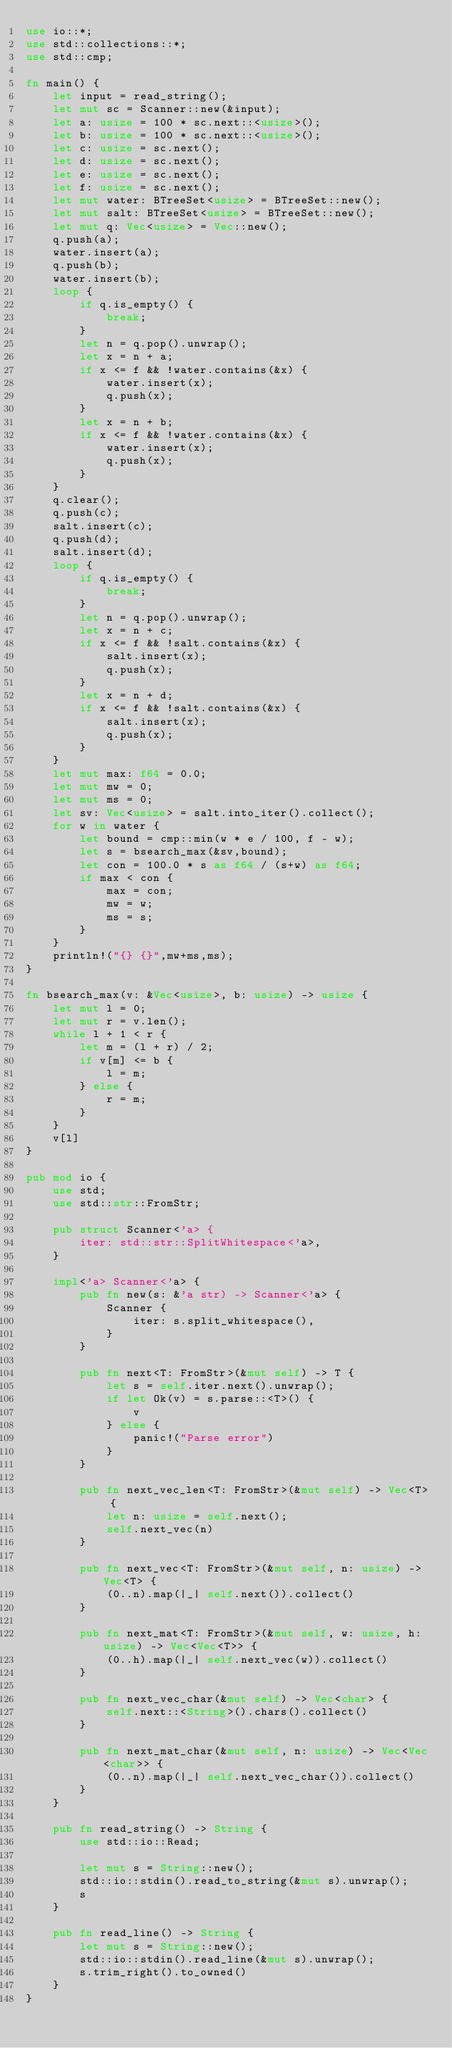<code> <loc_0><loc_0><loc_500><loc_500><_Rust_>use io::*;
use std::collections::*;
use std::cmp;

fn main() {
    let input = read_string();
    let mut sc = Scanner::new(&input);
    let a: usize = 100 * sc.next::<usize>();
    let b: usize = 100 * sc.next::<usize>();
    let c: usize = sc.next();
    let d: usize = sc.next();
    let e: usize = sc.next();
    let f: usize = sc.next();
    let mut water: BTreeSet<usize> = BTreeSet::new();
    let mut salt: BTreeSet<usize> = BTreeSet::new();
    let mut q: Vec<usize> = Vec::new();
    q.push(a);
    water.insert(a);
    q.push(b);
    water.insert(b);
    loop {
        if q.is_empty() {
            break;
        }
        let n = q.pop().unwrap();
        let x = n + a;
        if x <= f && !water.contains(&x) {
            water.insert(x);
            q.push(x);
        }
        let x = n + b;
        if x <= f && !water.contains(&x) {
            water.insert(x);
            q.push(x);
        }
    }
    q.clear();
    q.push(c);
    salt.insert(c);
    q.push(d);
    salt.insert(d);
    loop {
        if q.is_empty() {
            break;
        }
        let n = q.pop().unwrap();
        let x = n + c;
        if x <= f && !salt.contains(&x) {
            salt.insert(x);
            q.push(x);
        }
        let x = n + d;
        if x <= f && !salt.contains(&x) {
            salt.insert(x);
            q.push(x);
        }
    }
    let mut max: f64 = 0.0;
    let mut mw = 0;
    let mut ms = 0;
    let sv: Vec<usize> = salt.into_iter().collect();
    for w in water {
        let bound = cmp::min(w * e / 100, f - w);
        let s = bsearch_max(&sv,bound);
        let con = 100.0 * s as f64 / (s+w) as f64;
        if max < con {
            max = con;
            mw = w;
            ms = s;
        }
    }
    println!("{} {}",mw+ms,ms);
}

fn bsearch_max(v: &Vec<usize>, b: usize) -> usize {
    let mut l = 0;
    let mut r = v.len();
    while l + 1 < r {
        let m = (l + r) / 2;
        if v[m] <= b {
            l = m;
        } else {
            r = m;
        }
    }
    v[l]
}

pub mod io {
    use std;
    use std::str::FromStr;

    pub struct Scanner<'a> {
        iter: std::str::SplitWhitespace<'a>,
    }

    impl<'a> Scanner<'a> {
        pub fn new(s: &'a str) -> Scanner<'a> {
            Scanner {
                iter: s.split_whitespace(),
            }
        }

        pub fn next<T: FromStr>(&mut self) -> T {
            let s = self.iter.next().unwrap();
            if let Ok(v) = s.parse::<T>() {
                v
            } else {
                panic!("Parse error")
            }
        }

        pub fn next_vec_len<T: FromStr>(&mut self) -> Vec<T> {
            let n: usize = self.next();
            self.next_vec(n)
        }

        pub fn next_vec<T: FromStr>(&mut self, n: usize) -> Vec<T> {
            (0..n).map(|_| self.next()).collect()
        }

        pub fn next_mat<T: FromStr>(&mut self, w: usize, h: usize) -> Vec<Vec<T>> {
            (0..h).map(|_| self.next_vec(w)).collect()
        }

        pub fn next_vec_char(&mut self) -> Vec<char> {
            self.next::<String>().chars().collect()
        }

        pub fn next_mat_char(&mut self, n: usize) -> Vec<Vec<char>> {
            (0..n).map(|_| self.next_vec_char()).collect()
        }
    }

    pub fn read_string() -> String {
        use std::io::Read;

        let mut s = String::new();
        std::io::stdin().read_to_string(&mut s).unwrap();
        s
    }

    pub fn read_line() -> String {
        let mut s = String::new();
        std::io::stdin().read_line(&mut s).unwrap();
        s.trim_right().to_owned()
    }
}
</code> 